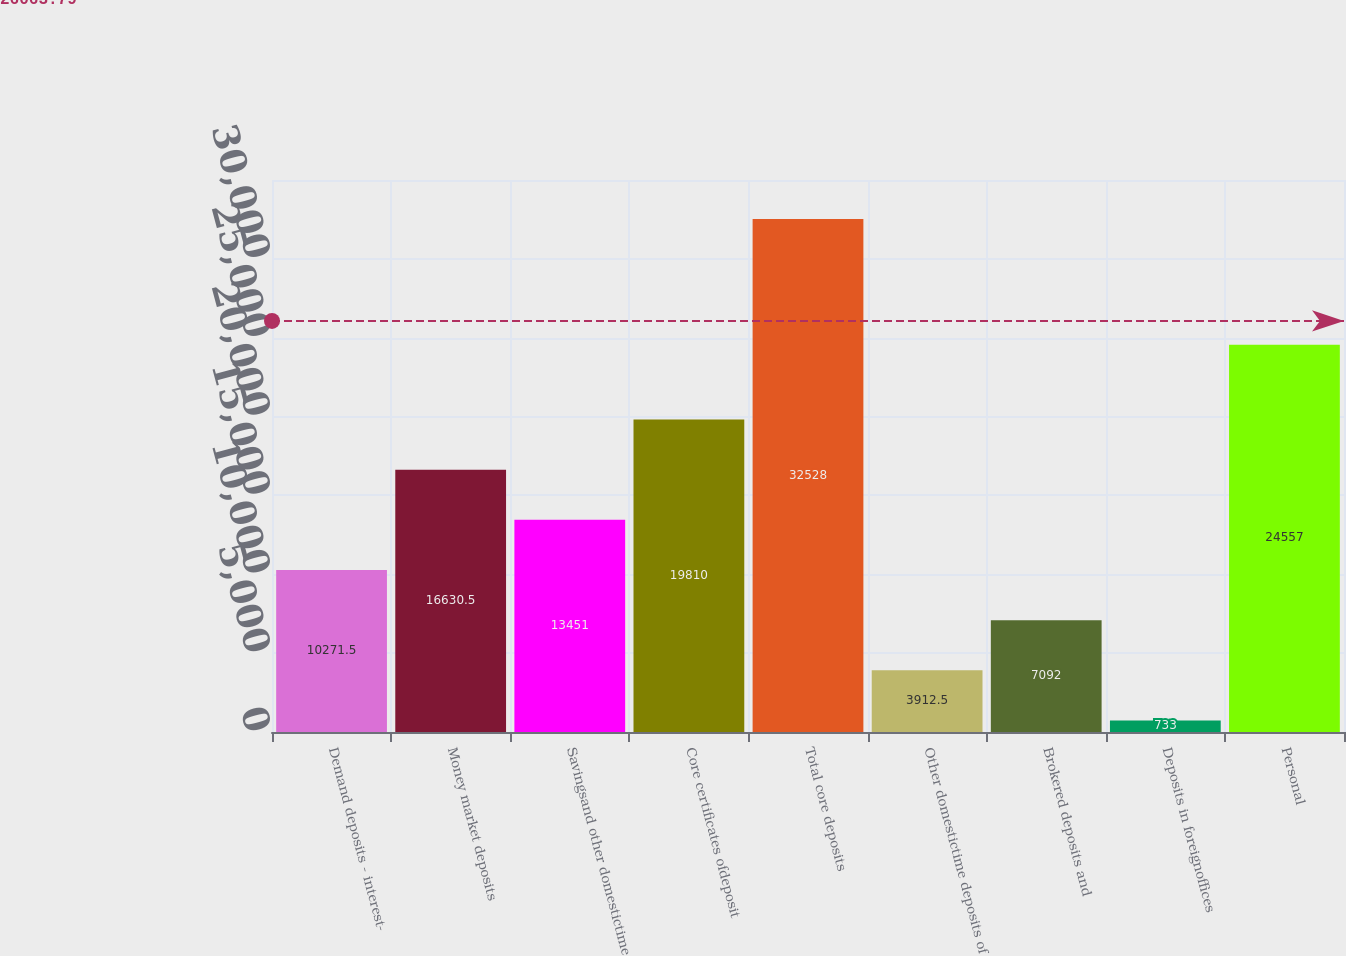Convert chart. <chart><loc_0><loc_0><loc_500><loc_500><bar_chart><fcel>Demand deposits - interest-<fcel>Money market deposits<fcel>Savingsand other domestictime<fcel>Core certificates ofdeposit<fcel>Total core deposits<fcel>Other domestictime deposits of<fcel>Brokered deposits and<fcel>Deposits in foreignoffices<fcel>Personal<nl><fcel>10271.5<fcel>16630.5<fcel>13451<fcel>19810<fcel>32528<fcel>3912.5<fcel>7092<fcel>733<fcel>24557<nl></chart> 